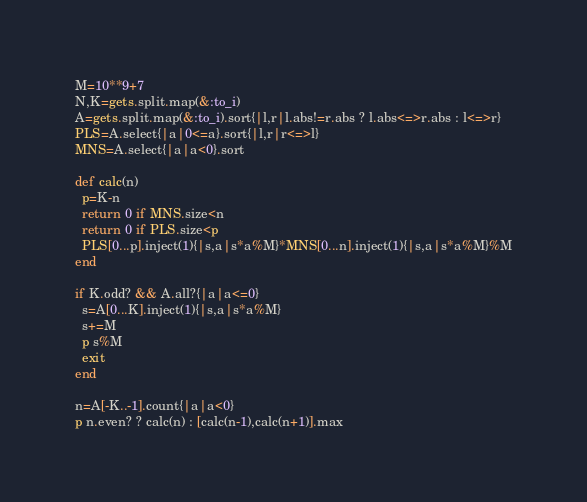<code> <loc_0><loc_0><loc_500><loc_500><_Ruby_>M=10**9+7
N,K=gets.split.map(&:to_i)
A=gets.split.map(&:to_i).sort{|l,r|l.abs!=r.abs ? l.abs<=>r.abs : l<=>r}
PLS=A.select{|a|0<=a}.sort{|l,r|r<=>l}
MNS=A.select{|a|a<0}.sort

def calc(n)
  p=K-n
  return 0 if MNS.size<n
  return 0 if PLS.size<p
  PLS[0...p].inject(1){|s,a|s*a%M}*MNS[0...n].inject(1){|s,a|s*a%M}%M
end

if K.odd? && A.all?{|a|a<=0}
  s=A[0...K].inject(1){|s,a|s*a%M}
  s+=M
  p s%M
  exit
end

n=A[-K..-1].count{|a|a<0}
p n.even? ? calc(n) : [calc(n-1),calc(n+1)].max</code> 